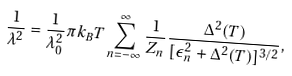Convert formula to latex. <formula><loc_0><loc_0><loc_500><loc_500>\frac { 1 } { \lambda ^ { 2 } } = \frac { 1 } { \lambda _ { 0 } ^ { 2 } } \pi k _ { B } T \sum _ { n = - \infty } ^ { \infty } \frac { 1 } { Z _ { n } } \frac { \Delta ^ { 2 } ( T ) } { [ \epsilon _ { n } ^ { 2 } + \Delta ^ { 2 } ( T ) ] ^ { 3 / 2 } } ,</formula> 